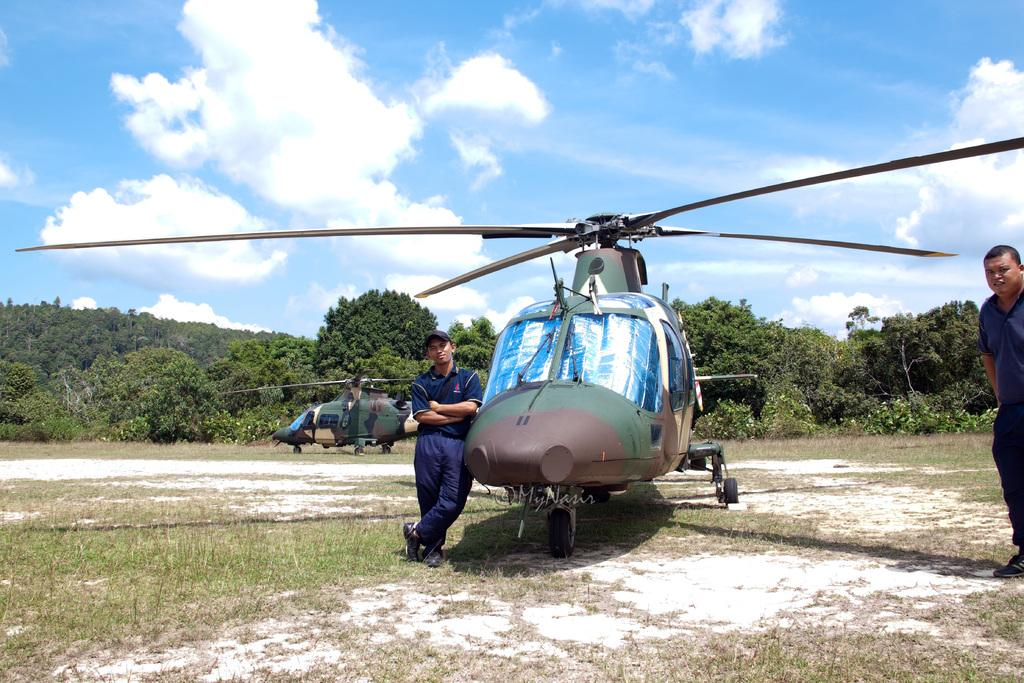What type of vehicles are in the image? There are helicopters in the image. How many people are in the image? There are two persons in the image. What is the ground surface like in the image? There is grass on the ground in the image. What can be seen in the background of the image? There are trees in the background of the image. What is visible in the sky in the image? The sky is visible in the image, and clouds are present. Where is the pump located in the image? There is no pump present in the image. Who is sitting on the throne in the image? There is no throne present in the image. 